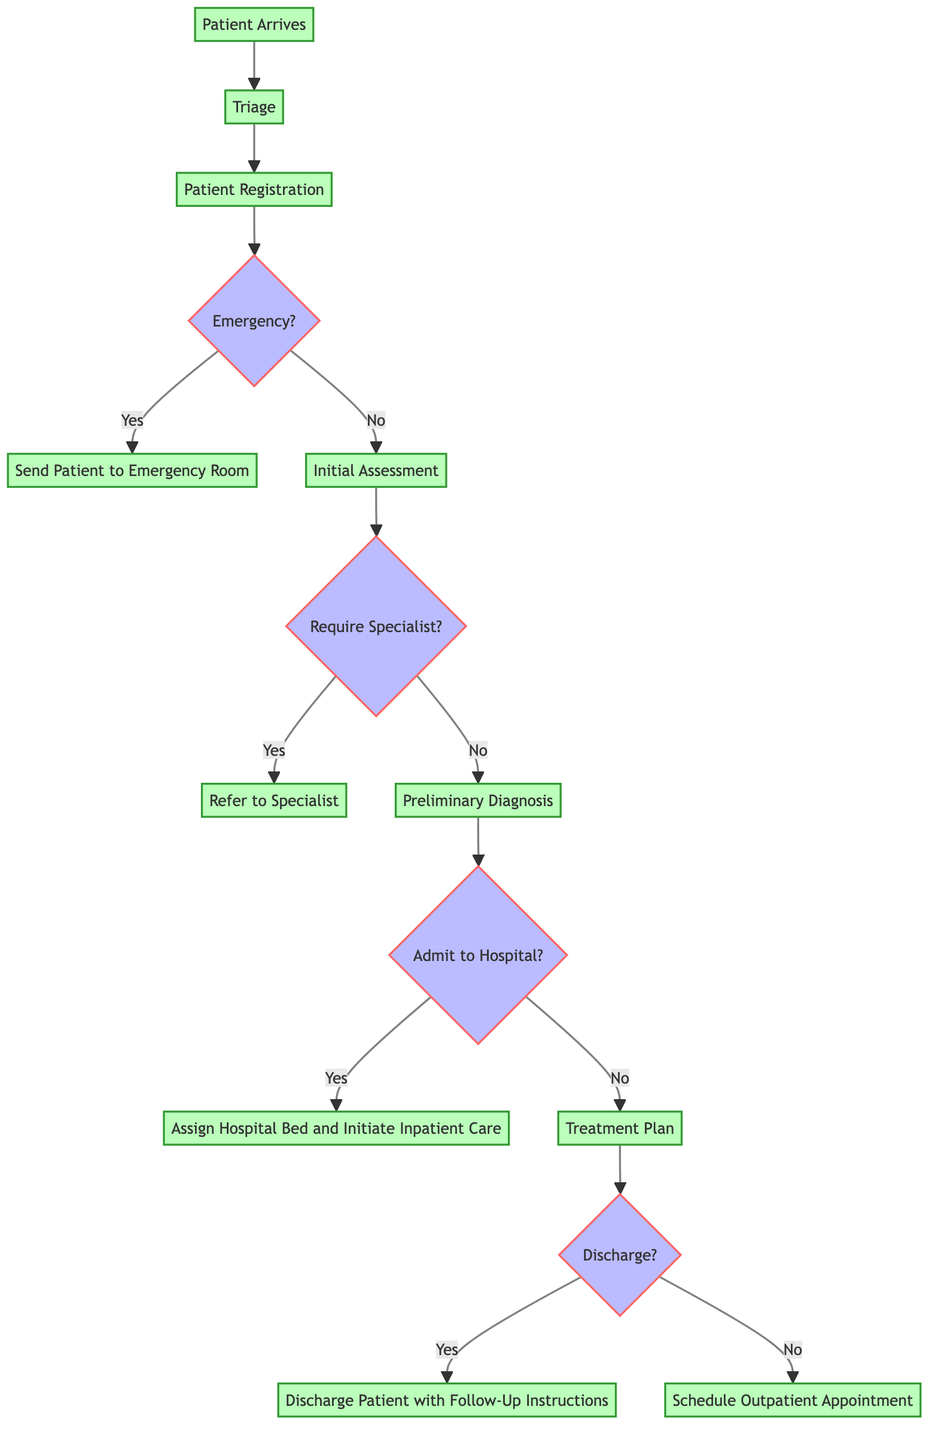What is the starting point in the workflow? The starting point in the workflow is where the process begins, which is indicated as "Patient Arrives." This is clearly labeled at the beginning of the diagram.
Answer: Patient Arrives How many decision points are in the diagram? In the diagram, there are four decision points indicated by diamond shapes. Each decision point corresponds to a critical choice in the workflow.
Answer: Four What happens if the patient does not require a specialist? If the patient does not require a specialist, the workflow proceeds to the "Preliminary Diagnosis" step. This is directly indicated after the decision "Require Specialist?" which branches off to "No."
Answer: Proceed to Preliminary Diagnosis What is the end result if the patient is discharged? If the patient is discharged, the end result is "Discharge Patient with Follow-Up Instructions." This is the final endpoint following the decision "Discharge?" which branches off to "Yes."
Answer: Discharge Patient with Follow-Up Instructions What step follows the Patient Registration if the patient is not in an emergency condition? If the patient is not in an emergency condition, the step that follows "Patient Registration" is "Initial Assessment." This is part of the workflow leading from the decision point related to emergency status.
Answer: Initial Assessment What action is taken if the preliminary diagnosis indicates that the patient should be admitted to the hospital? If the preliminary diagnosis indicates admission to the hospital, the action taken is to "Assign Hospital Bed and Initiate Inpatient Care." This is the outcome indicated by "Yes" from the decision point "Admit to Hospital?"
Answer: Assign Hospital Bed and Initiate Inpatient Care What is the relationship between "Initial Assessment" and "Preliminary Diagnosis"? The relationship is sequential; the "Initial Assessment" must occur before reaching the "Preliminary Diagnosis" step. This sequencing is indicated by a direct arrow connecting these two steps in the diagram.
Answer: Sequential What occurs at the decision point labeled "Discharge?" if the answer is no? If the answer at the decision point "Discharge?" is no, then the next action taken is to "Schedule Outpatient Appointment." This result is clearly bifurcated from the decision point in the diagram.
Answer: Schedule Outpatient Appointment 